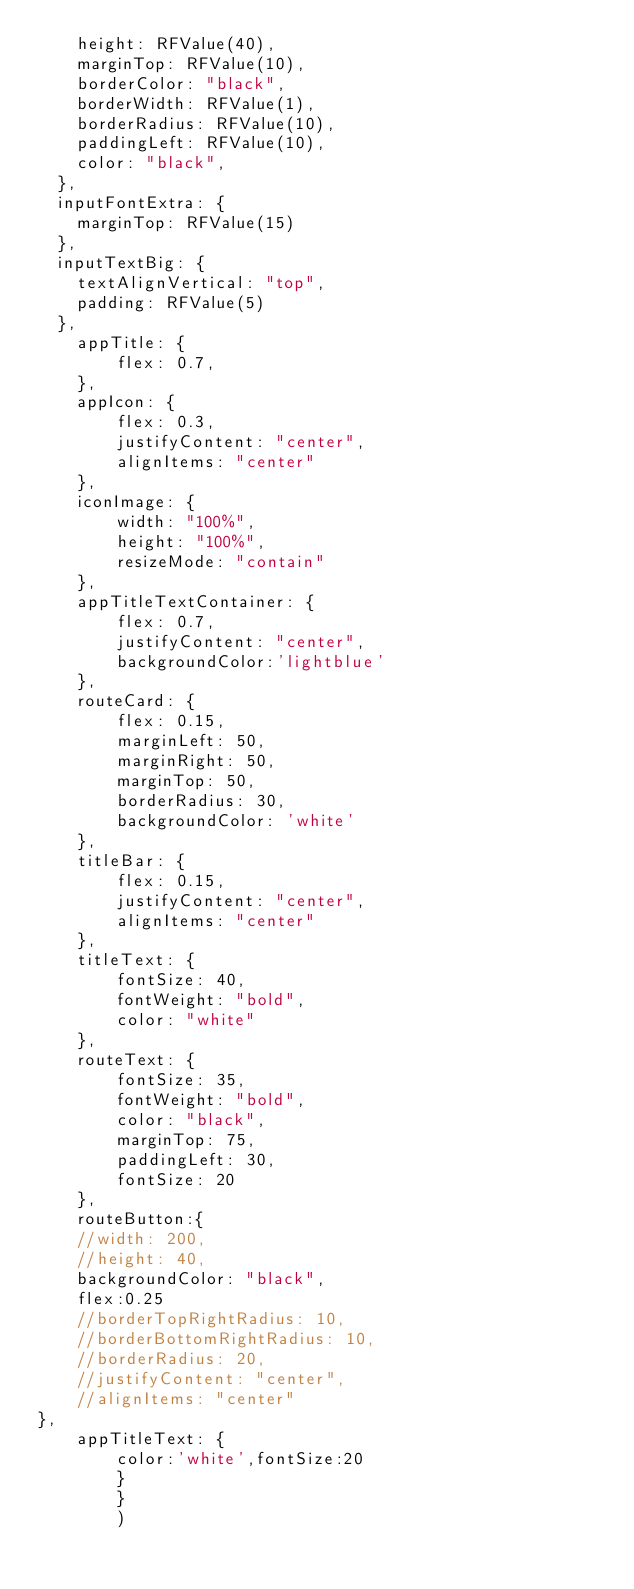Convert code to text. <code><loc_0><loc_0><loc_500><loc_500><_JavaScript_>    height: RFValue(40),
	marginTop: RFValue(10),
    borderColor: "black",
    borderWidth: RFValue(1),
    borderRadius: RFValue(10),
    paddingLeft: RFValue(10),
    color: "black",
  },
  inputFontExtra: {
    marginTop: RFValue(15)
  },
  inputTextBig: {
    textAlignVertical: "top",
    padding: RFValue(5)
  },
	appTitle: {
		flex: 0.7,
	},
	appIcon: {
		flex: 0.3,
		justifyContent: "center",
		alignItems: "center"
	},
	iconImage: {
		width: "100%",
		height: "100%",
		resizeMode: "contain"
	},
	appTitleTextContainer: {
		flex: 0.7,
		justifyContent: "center",
		backgroundColor:'lightblue'
	},
    routeCard: {
        flex: 0.15,
        marginLeft: 50,
        marginRight: 50,
        marginTop: 50,
        borderRadius: 30,
        backgroundColor: 'white'
    },
    titleBar: {
        flex: 0.15,
        justifyContent: "center",
        alignItems: "center"
    },
    titleText: {
        fontSize: 40,
        fontWeight: "bold",
        color: "white"
    },
    routeText: {
        fontSize: 35,
        fontWeight: "bold",
        color: "black",
        marginTop: 75,
        paddingLeft: 30,
        fontSize: 20
    },
	routeButton:{
	//width: 200,
    //height: 40,
    backgroundColor: "black",
    flex:0.25
    //borderTopRightRadius: 10,
    //borderBottomRightRadius: 10,
	//borderRadius: 20,
    //justifyContent: "center",
    //alignItems: "center"
},
	appTitleText: {
		color:'white',fontSize:20
		}
		}
		)</code> 